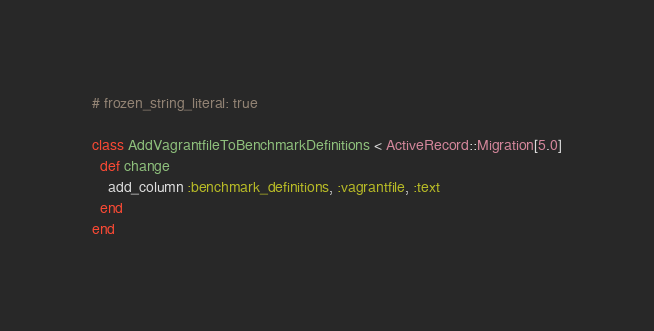<code> <loc_0><loc_0><loc_500><loc_500><_Ruby_># frozen_string_literal: true

class AddVagrantfileToBenchmarkDefinitions < ActiveRecord::Migration[5.0]
  def change
    add_column :benchmark_definitions, :vagrantfile, :text
  end
end
</code> 